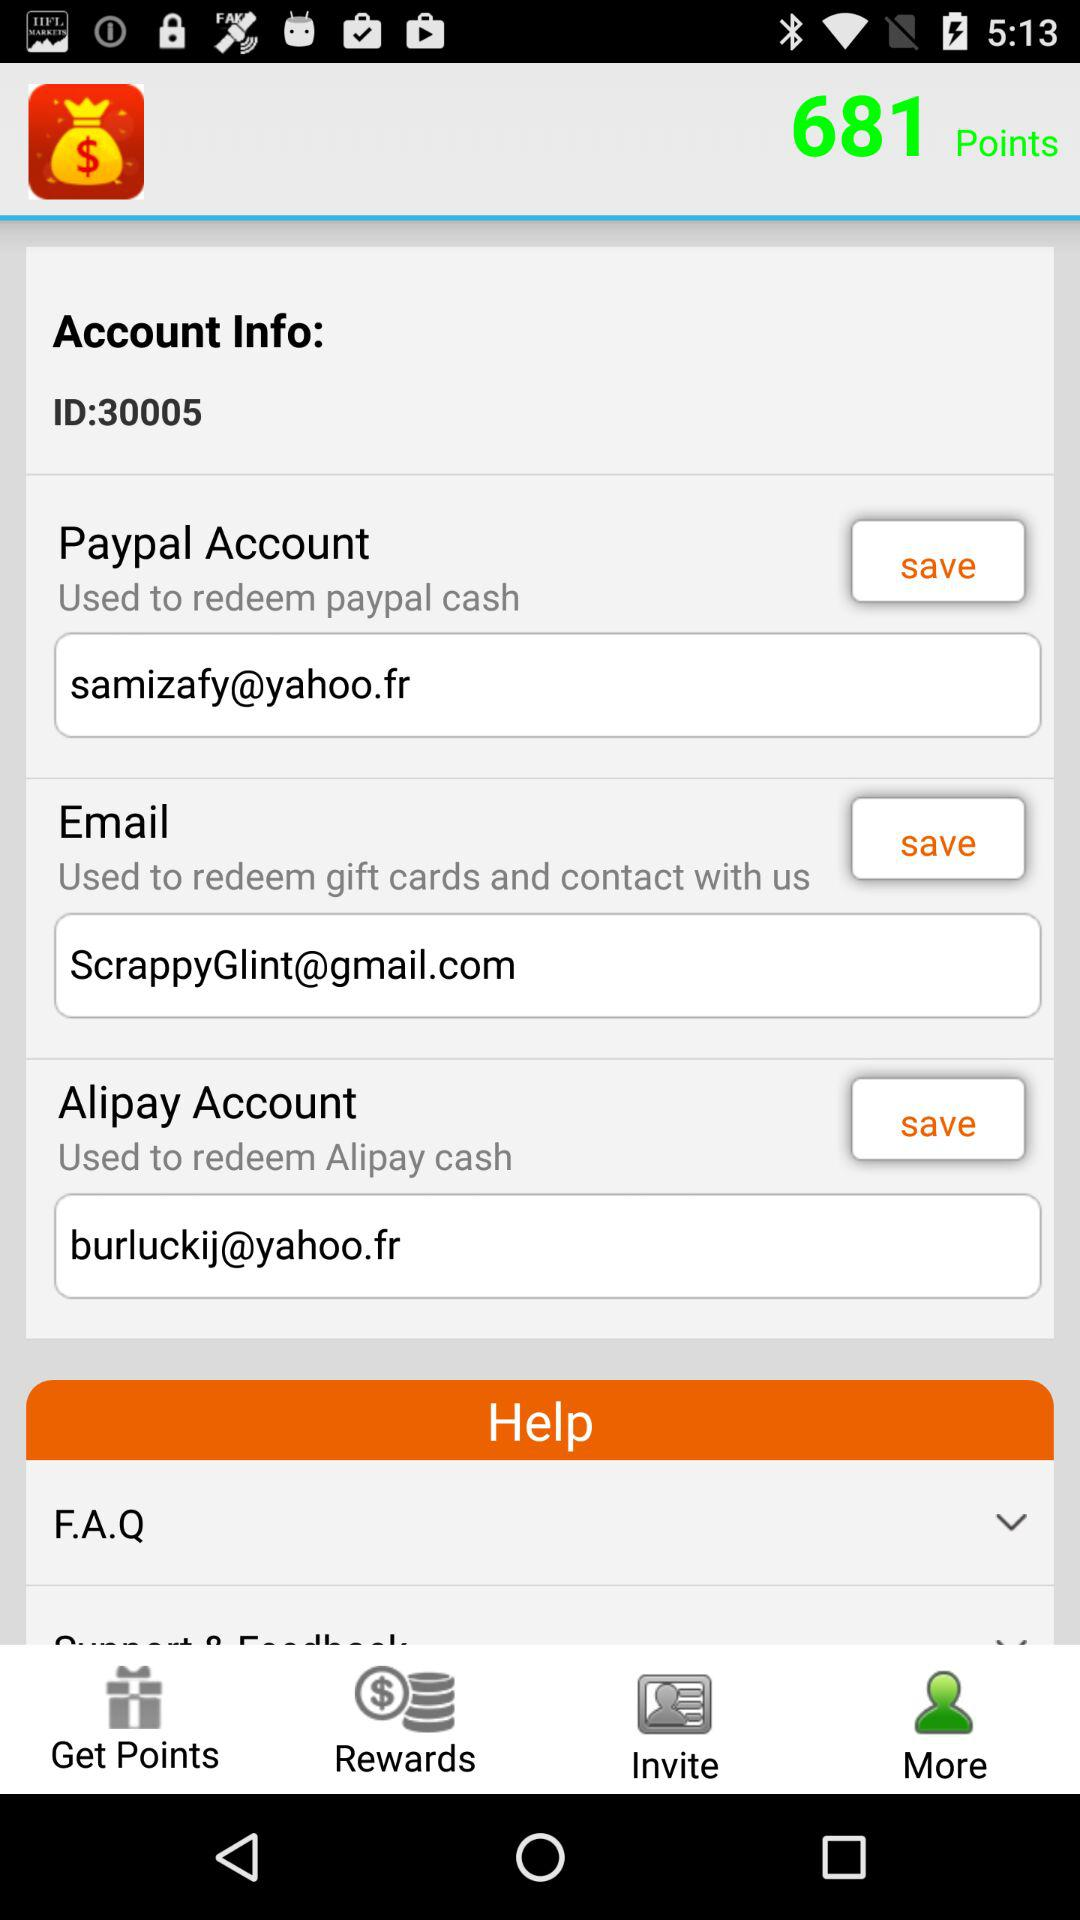What is the email address? The email addresses are samizafy@yahoo.fr, ScrappyGlint@gmail.com and burluckij@yahoo.fr. 